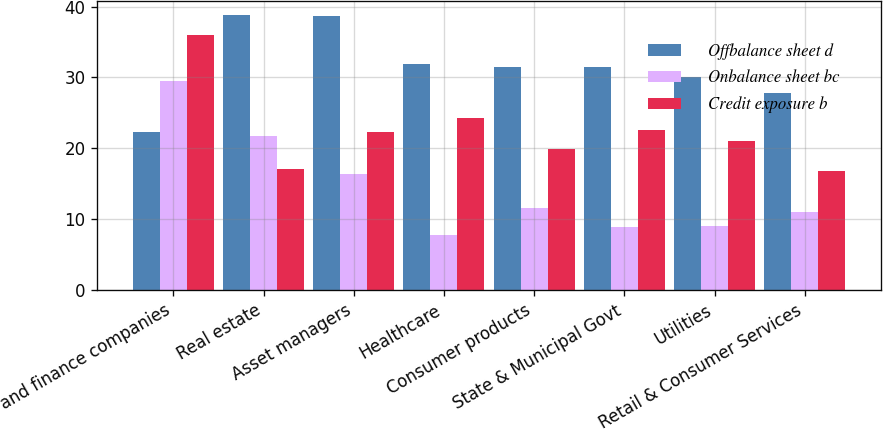<chart> <loc_0><loc_0><loc_500><loc_500><stacked_bar_chart><ecel><fcel>Banks and finance companies<fcel>Real estate<fcel>Asset managers<fcel>Healthcare<fcel>Consumer products<fcel>State & Municipal Govt<fcel>Utilities<fcel>Retail & Consumer Services<nl><fcel>Offbalance sheet d<fcel>22.3<fcel>38.8<fcel>38.7<fcel>31.9<fcel>31.5<fcel>31.4<fcel>30<fcel>27.8<nl><fcel>Onbalance sheet bc<fcel>29.5<fcel>21.7<fcel>16.4<fcel>7.7<fcel>11.6<fcel>8.9<fcel>9<fcel>11<nl><fcel>Credit exposure b<fcel>36<fcel>17.1<fcel>22.3<fcel>24.2<fcel>19.9<fcel>22.5<fcel>21<fcel>16.8<nl></chart> 